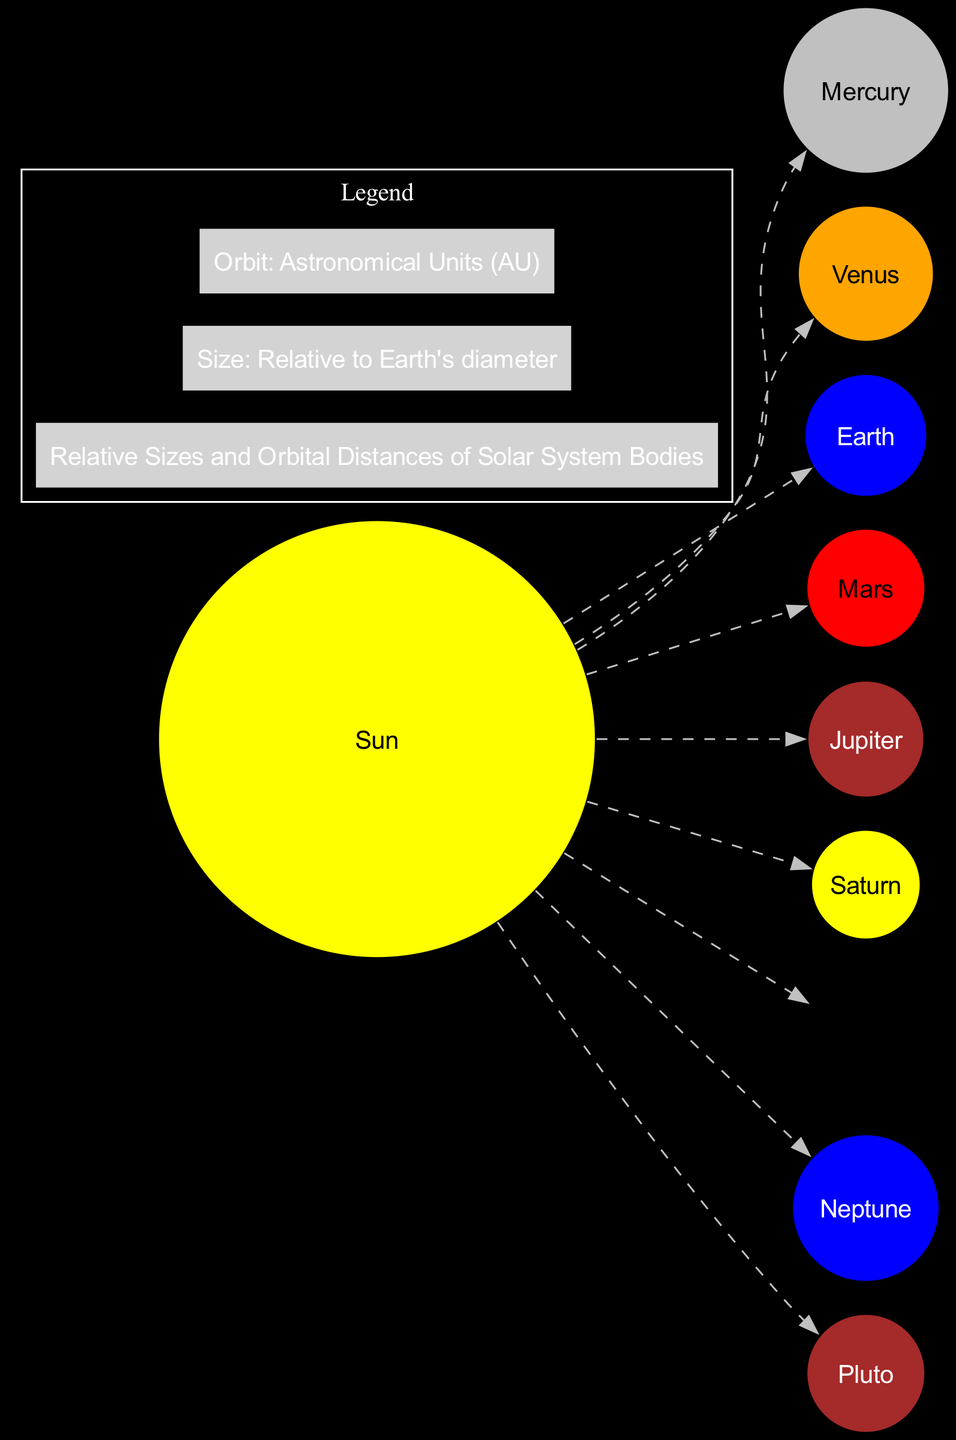What is the relative size of Jupiter? The diagram shows that Jupiter has a relative size of 11.21, which indicates it is significantly larger than Earth, whose relative size is 1. This value represents Jupiter's diameter in comparison to Earth's diameter.
Answer: 11.21 What color is Venus represented in the diagram? The diagram depicts Venus in an orange color, indicating its distinctive appearance among the planets. This information can be found by looking at the color associated with the Venus circle in the diagram.
Answer: Orange How many planets are there in the solar system representation? By counting the total number of circles representing the planets, excluding the Sun, it is clear that there are eight planets included in this artistic representation. This includes Mercury, Venus, Earth, Mars, Jupiter, Saturn, Uranus, and Neptune.
Answer: Eight What is the orbit distance of Neptune from the Sun in AU? The diagram specifies Neptune’s orbit distance from the Sun as 30.05 AU. To find this, one can refer to the specified orbital distance for Neptune in the diagram's data.
Answer: 30.05 Which planet has the smallest relative size? Comparing the relative sizes of all planets, Pluto has the smallest relative size at 0.186. This is determined by looking at the size relative to Earth's diameter for each planet listed in the diagram.
Answer: Pluto Which planet is known as the Red Planet? According to the diagram, Mars is referred to as the Red Planet due to its iron oxide surface, which reflects a reddish hue. This label can be found in the description associated with Mars in the diagram.
Answer: Mars What is the color of Saturn? The diagram shows Saturn represented in yellow, indicating its recognized color among the planets. This information is obtained by checking the color associated with the Saturn circle in the diagram.
Answer: Yellow How far is Mercury from the Sun in AU? The corresponding orbit distance for Mercury from the Sun in the diagram is shown as 0.39 AU. This numerical value reveals Mercury's position relative to the Sun as the closest planet within the solar system.
Answer: 0.39 Which planet has a prominent Great Red Spot? The diagram attributes the prominent Great Red Spot to Jupiter, indicating its unique feature among the solar system planets. This information is available in Jupiter's description within the diagram.
Answer: Jupiter 